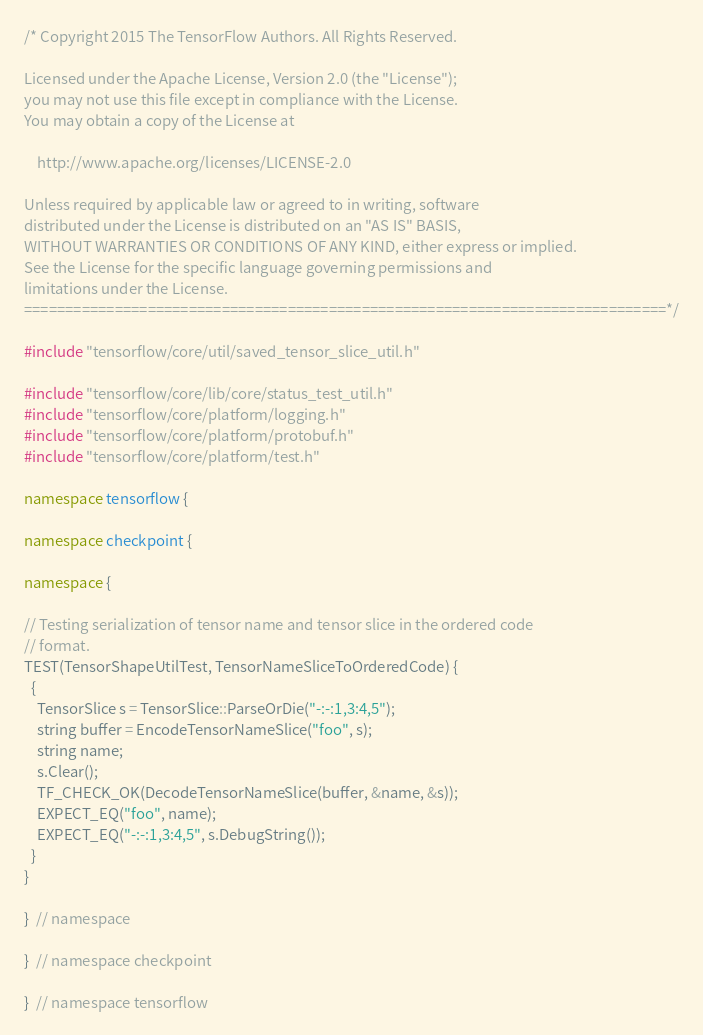<code> <loc_0><loc_0><loc_500><loc_500><_C++_>/* Copyright 2015 The TensorFlow Authors. All Rights Reserved.

Licensed under the Apache License, Version 2.0 (the "License");
you may not use this file except in compliance with the License.
You may obtain a copy of the License at

    http://www.apache.org/licenses/LICENSE-2.0

Unless required by applicable law or agreed to in writing, software
distributed under the License is distributed on an "AS IS" BASIS,
WITHOUT WARRANTIES OR CONDITIONS OF ANY KIND, either express or implied.
See the License for the specific language governing permissions and
limitations under the License.
==============================================================================*/

#include "tensorflow/core/util/saved_tensor_slice_util.h"

#include "tensorflow/core/lib/core/status_test_util.h"
#include "tensorflow/core/platform/logging.h"
#include "tensorflow/core/platform/protobuf.h"
#include "tensorflow/core/platform/test.h"

namespace tensorflow {

namespace checkpoint {

namespace {

// Testing serialization of tensor name and tensor slice in the ordered code
// format.
TEST(TensorShapeUtilTest, TensorNameSliceToOrderedCode) {
  {
    TensorSlice s = TensorSlice::ParseOrDie("-:-:1,3:4,5");
    string buffer = EncodeTensorNameSlice("foo", s);
    string name;
    s.Clear();
    TF_CHECK_OK(DecodeTensorNameSlice(buffer, &name, &s));
    EXPECT_EQ("foo", name);
    EXPECT_EQ("-:-:1,3:4,5", s.DebugString());
  }
}

}  // namespace

}  // namespace checkpoint

}  // namespace tensorflow
</code> 